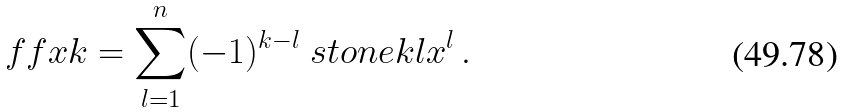<formula> <loc_0><loc_0><loc_500><loc_500>\ f f { x } { k } = \sum _ { l = 1 } ^ { n } ( - 1 ) ^ { k - l } \ s t o n e { k } { l } x ^ { l } \, .</formula> 